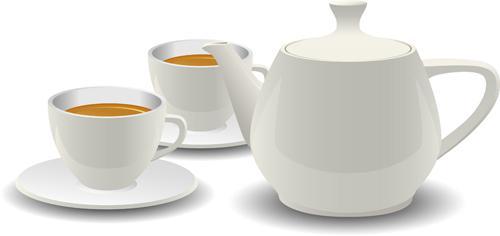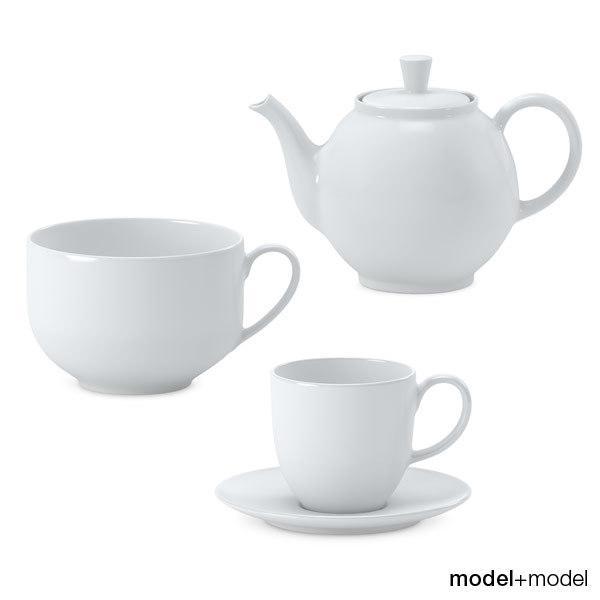The first image is the image on the left, the second image is the image on the right. Assess this claim about the two images: "An image shows a white pitcher next to at least one filled mug on a saucer.". Correct or not? Answer yes or no. Yes. The first image is the image on the left, the second image is the image on the right. Assess this claim about the two images: "The pitcher near the coffee is white.". Correct or not? Answer yes or no. Yes. 